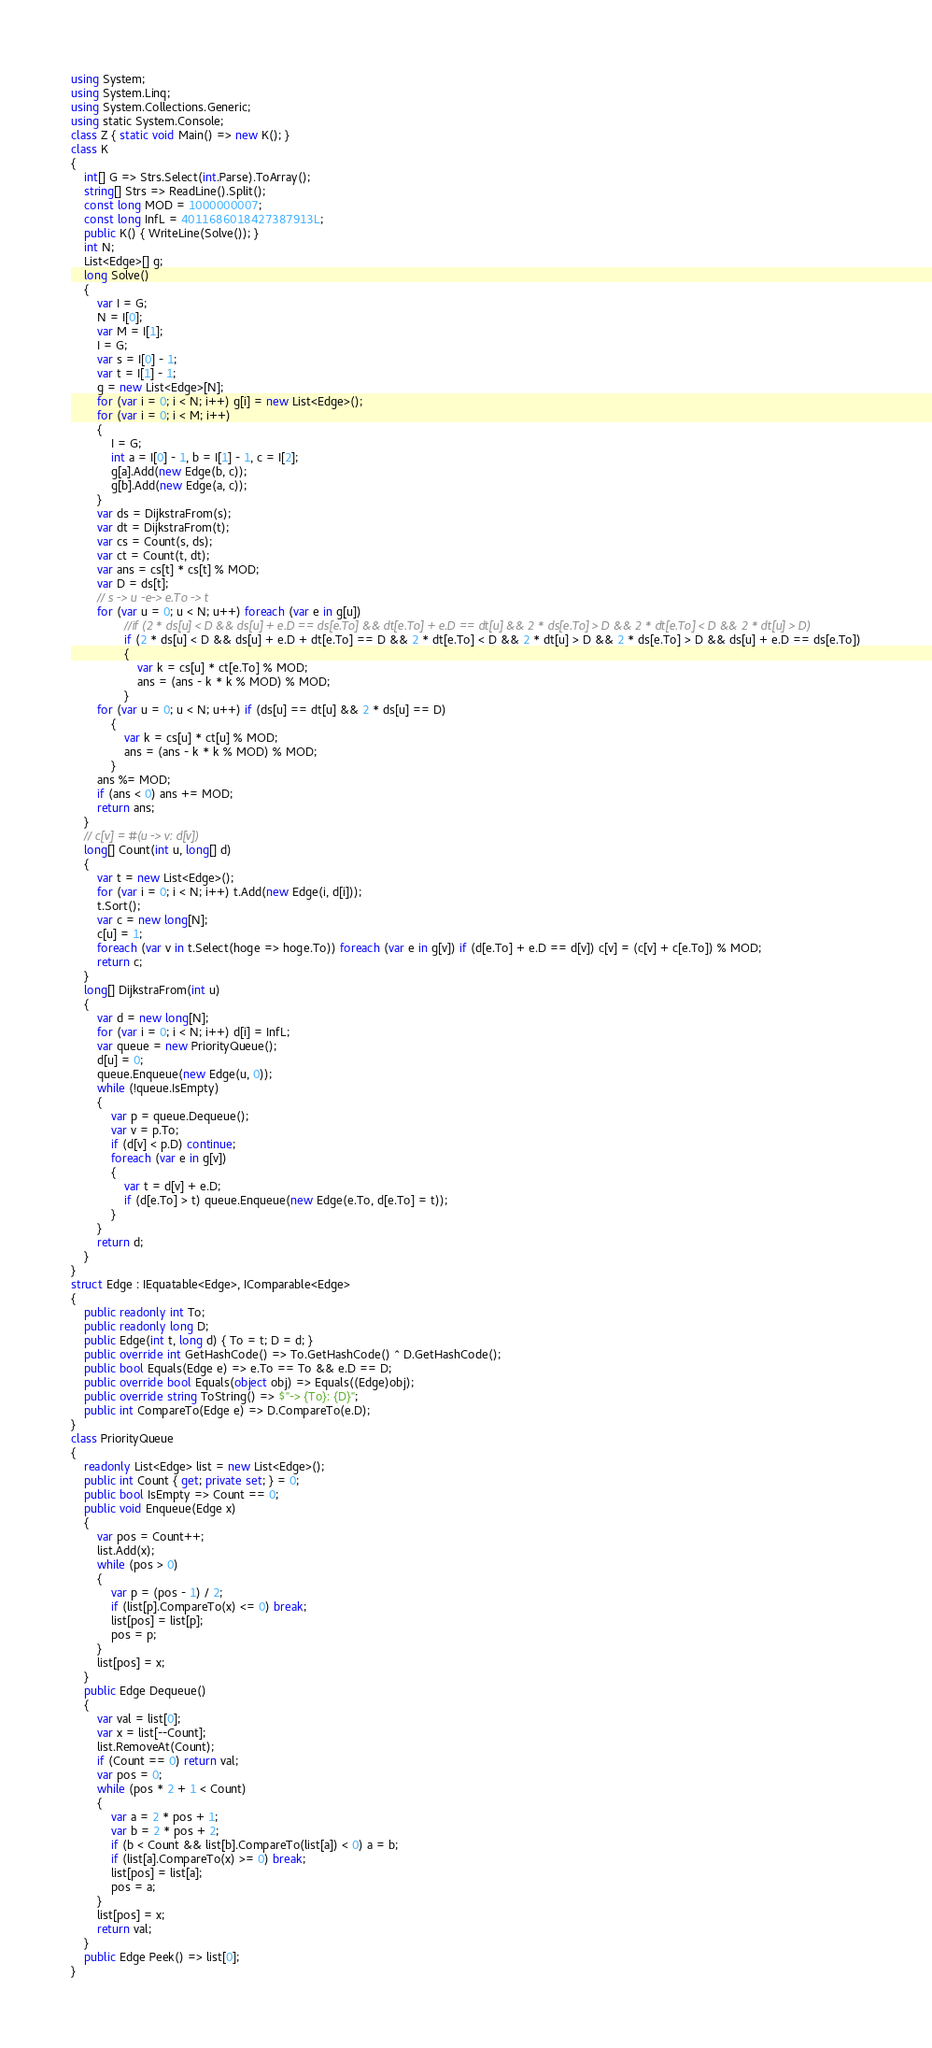Convert code to text. <code><loc_0><loc_0><loc_500><loc_500><_C#_>using System;
using System.Linq;
using System.Collections.Generic;
using static System.Console;
class Z { static void Main() => new K(); }
class K
{
	int[] G => Strs.Select(int.Parse).ToArray();
	string[] Strs => ReadLine().Split();
	const long MOD = 1000000007;
	const long InfL = 4011686018427387913L;
	public K() { WriteLine(Solve()); }
	int N;
	List<Edge>[] g;
	long Solve()
	{
		var I = G;
		N = I[0];
		var M = I[1];
		I = G;
		var s = I[0] - 1;
		var t = I[1] - 1;
		g = new List<Edge>[N];
		for (var i = 0; i < N; i++) g[i] = new List<Edge>();
		for (var i = 0; i < M; i++)
		{
			I = G;
			int a = I[0] - 1, b = I[1] - 1, c = I[2];
			g[a].Add(new Edge(b, c));
			g[b].Add(new Edge(a, c));
		}
		var ds = DijkstraFrom(s);
		var dt = DijkstraFrom(t);
		var cs = Count(s, ds);
		var ct = Count(t, dt);
		var ans = cs[t] * cs[t] % MOD;
		var D = ds[t];
		// s -> u -e-> e.To -> t
		for (var u = 0; u < N; u++) foreach (var e in g[u])
				//if (2 * ds[u] < D && ds[u] + e.D == ds[e.To] && dt[e.To] + e.D == dt[u] && 2 * ds[e.To] > D && 2 * dt[e.To] < D && 2 * dt[u] > D)
				if (2 * ds[u] < D && ds[u] + e.D + dt[e.To] == D && 2 * dt[e.To] < D && 2 * dt[u] > D && 2 * ds[e.To] > D && ds[u] + e.D == ds[e.To])
				{
					var k = cs[u] * ct[e.To] % MOD;
					ans = (ans - k * k % MOD) % MOD;
				}
		for (var u = 0; u < N; u++) if (ds[u] == dt[u] && 2 * ds[u] == D)
			{
				var k = cs[u] * ct[u] % MOD;
				ans = (ans - k * k % MOD) % MOD;
			}
		ans %= MOD;
		if (ans < 0) ans += MOD;
		return ans;
	}
	// c[v] = #(u -> v: d[v])
	long[] Count(int u, long[] d)
	{
		var t = new List<Edge>();
		for (var i = 0; i < N; i++) t.Add(new Edge(i, d[i]));
		t.Sort();
		var c = new long[N];
		c[u] = 1;
		foreach (var v in t.Select(hoge => hoge.To)) foreach (var e in g[v]) if (d[e.To] + e.D == d[v]) c[v] = (c[v] + c[e.To]) % MOD;
		return c;
	}
	long[] DijkstraFrom(int u)
	{
		var d = new long[N];
		for (var i = 0; i < N; i++) d[i] = InfL;
		var queue = new PriorityQueue();
		d[u] = 0;
		queue.Enqueue(new Edge(u, 0));
		while (!queue.IsEmpty)
		{
			var p = queue.Dequeue();
			var v = p.To;
			if (d[v] < p.D) continue;
			foreach (var e in g[v])
			{
				var t = d[v] + e.D;
				if (d[e.To] > t) queue.Enqueue(new Edge(e.To, d[e.To] = t));
			}
		}
		return d;
	}
}
struct Edge : IEquatable<Edge>, IComparable<Edge>
{
	public readonly int To;
	public readonly long D;
	public Edge(int t, long d) { To = t; D = d; }
	public override int GetHashCode() => To.GetHashCode() ^ D.GetHashCode();
	public bool Equals(Edge e) => e.To == To && e.D == D;
	public override bool Equals(object obj) => Equals((Edge)obj);
	public override string ToString() => $"-> {To}: {D}";
	public int CompareTo(Edge e) => D.CompareTo(e.D);
}
class PriorityQueue
{
	readonly List<Edge> list = new List<Edge>();
	public int Count { get; private set; } = 0;
	public bool IsEmpty => Count == 0;
	public void Enqueue(Edge x)
	{
		var pos = Count++;
		list.Add(x);
		while (pos > 0)
		{
			var p = (pos - 1) / 2;
			if (list[p].CompareTo(x) <= 0) break;
			list[pos] = list[p];
			pos = p;
		}
		list[pos] = x;
	}
	public Edge Dequeue()
	{
		var val = list[0];
		var x = list[--Count];
		list.RemoveAt(Count);
		if (Count == 0) return val;
		var pos = 0;
		while (pos * 2 + 1 < Count)
		{
			var a = 2 * pos + 1;
			var b = 2 * pos + 2;
			if (b < Count && list[b].CompareTo(list[a]) < 0) a = b;
			if (list[a].CompareTo(x) >= 0) break;
			list[pos] = list[a];
			pos = a;
		}
		list[pos] = x;
		return val;
	}
	public Edge Peek() => list[0];
}
</code> 